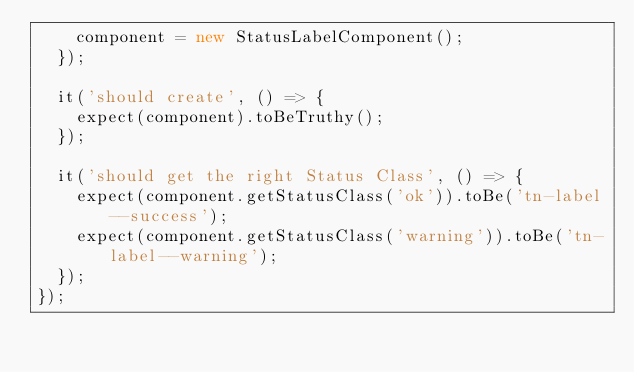Convert code to text. <code><loc_0><loc_0><loc_500><loc_500><_TypeScript_>    component = new StatusLabelComponent();
  });

  it('should create', () => {
    expect(component).toBeTruthy();
  });

  it('should get the right Status Class', () => {
    expect(component.getStatusClass('ok')).toBe('tn-label--success');
    expect(component.getStatusClass('warning')).toBe('tn-label--warning');
  });
});
</code> 